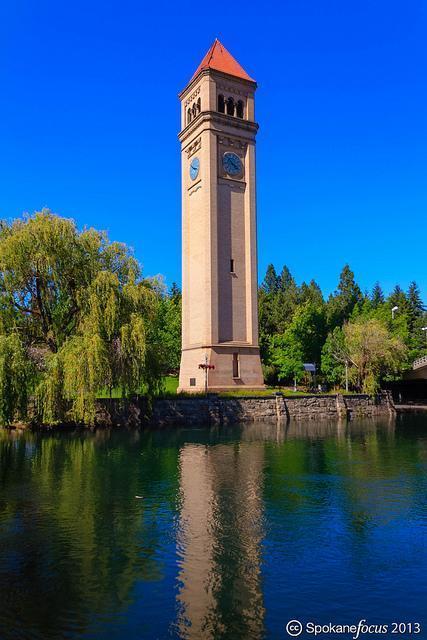How many people are swimming?
Give a very brief answer. 0. 